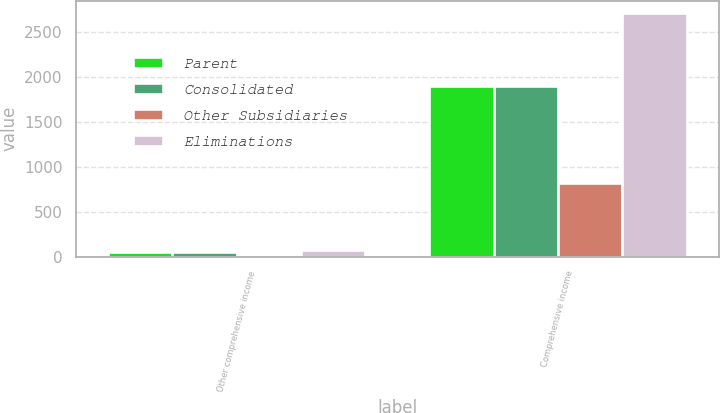Convert chart. <chart><loc_0><loc_0><loc_500><loc_500><stacked_bar_chart><ecel><fcel>Other comprehensive income<fcel>Comprehensive income<nl><fcel>Parent<fcel>49.6<fcel>1898.3<nl><fcel>Consolidated<fcel>49.6<fcel>1900.8<nl><fcel>Other Subsidiaries<fcel>23.6<fcel>816.4<nl><fcel>Eliminations<fcel>72.4<fcel>2717.1<nl></chart> 